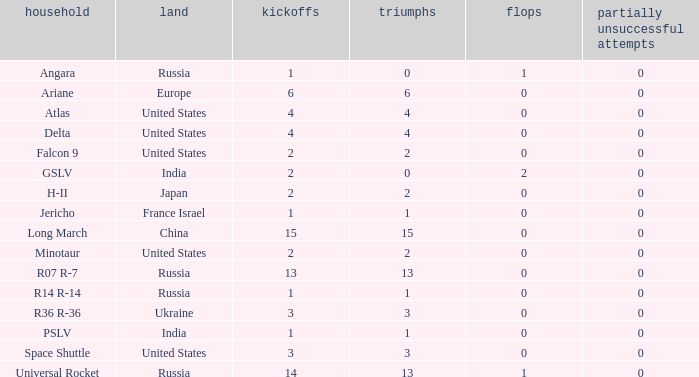What is the number of failure for the country of Russia, and a Family of r14 r-14, and a Partial failures smaller than 0? 0.0. 